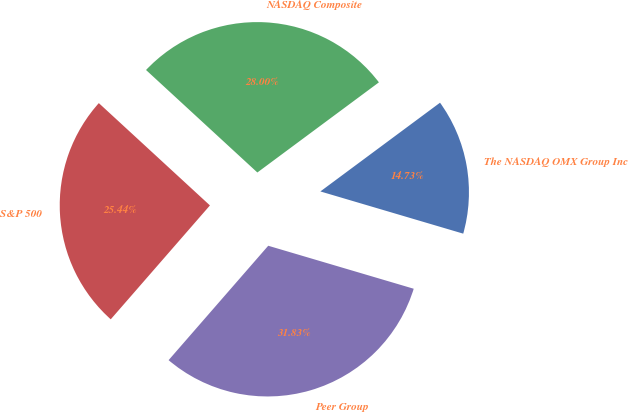Convert chart. <chart><loc_0><loc_0><loc_500><loc_500><pie_chart><fcel>The NASDAQ OMX Group Inc<fcel>NASDAQ Composite<fcel>S&P 500<fcel>Peer Group<nl><fcel>14.73%<fcel>28.0%<fcel>25.44%<fcel>31.83%<nl></chart> 